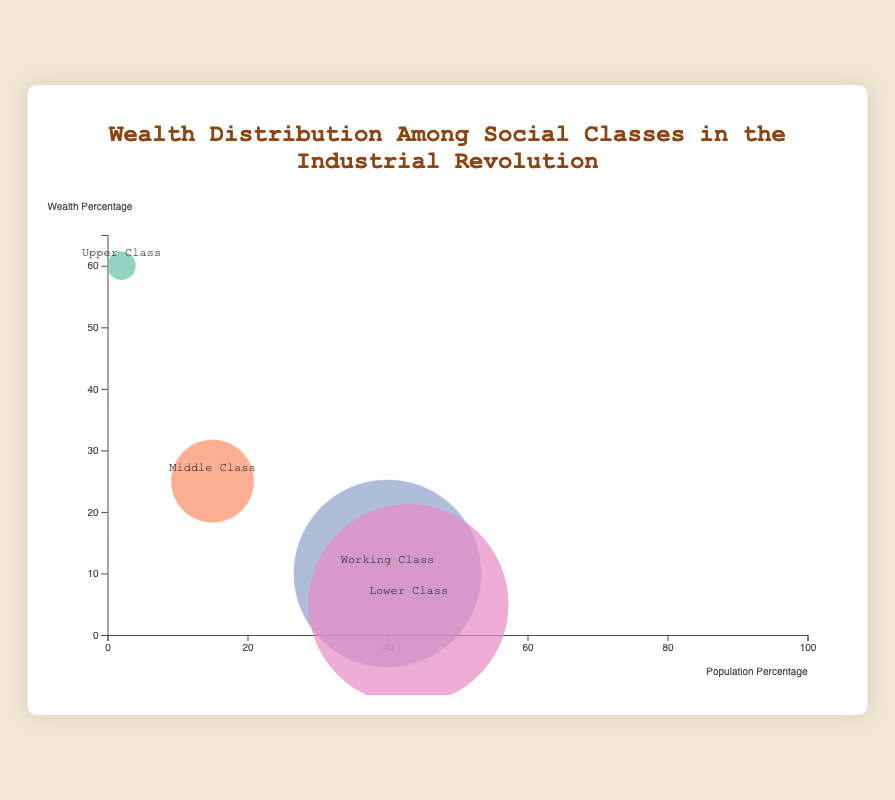What is the population percentage of the Lower Class? The Lower Class population percentage can be directly found on the figure by looking at the position of its bubble on the x-axis, which represents population percentage.
Answer: 43% What is the combined wealth percentage of the Upper Class and Middle Class? The wealth percentages are 60% for the Upper Class and 25% for the Middle Class. Adding these together gives 60% + 25% = 85%.
Answer: 85% Which social class has the highest wealth percentage, and what is it? By examining the y-axis, which represents wealth percentage, and finding the highest bubble on this axis, the Upper Class has the highest wealth percentage at 60%.
Answer: Upper Class, 60% How does the population percentage of the Working Class compare to the Middle Class? The population percentages are 40% for the Working Class and 15% for the Middle Class. Comparing these, the Working Class has a larger population percentage.
Answer: Working Class is larger What social class's bubble is the largest in size? The size of the bubble is proportional to the population percentage. The largest bubble, as per its radius, represents the Lower Class, which has a population percentage of 43%.
Answer: Lower Class If the wealth percentage of the Working Class and the Lower Class were combined, how would it compare to the wealth percentage of the Middle Class? The wealth percentages are 10% for the Working Class and 5% for the Lower Class. Adding these gives 10% + 5% = 15%. Comparing this to the Middle Class, which has a wealth percentage of 25%, shows that the combined wealth percentage is less than the Middle Class.
Answer: Less than the Middle Class Which social class occupies the smallest bubble on the chart? The smallest bubble corresponds to the social class with the smallest population percentage. The Upper Class, with a population percentage of 2%, has the smallest bubble.
Answer: Upper Class 